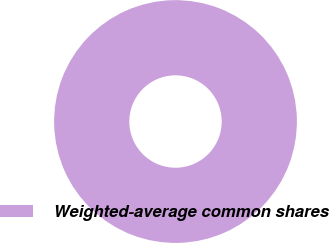Convert chart to OTSL. <chart><loc_0><loc_0><loc_500><loc_500><pie_chart><fcel>Weighted-average common shares<nl><fcel>100.0%<nl></chart> 